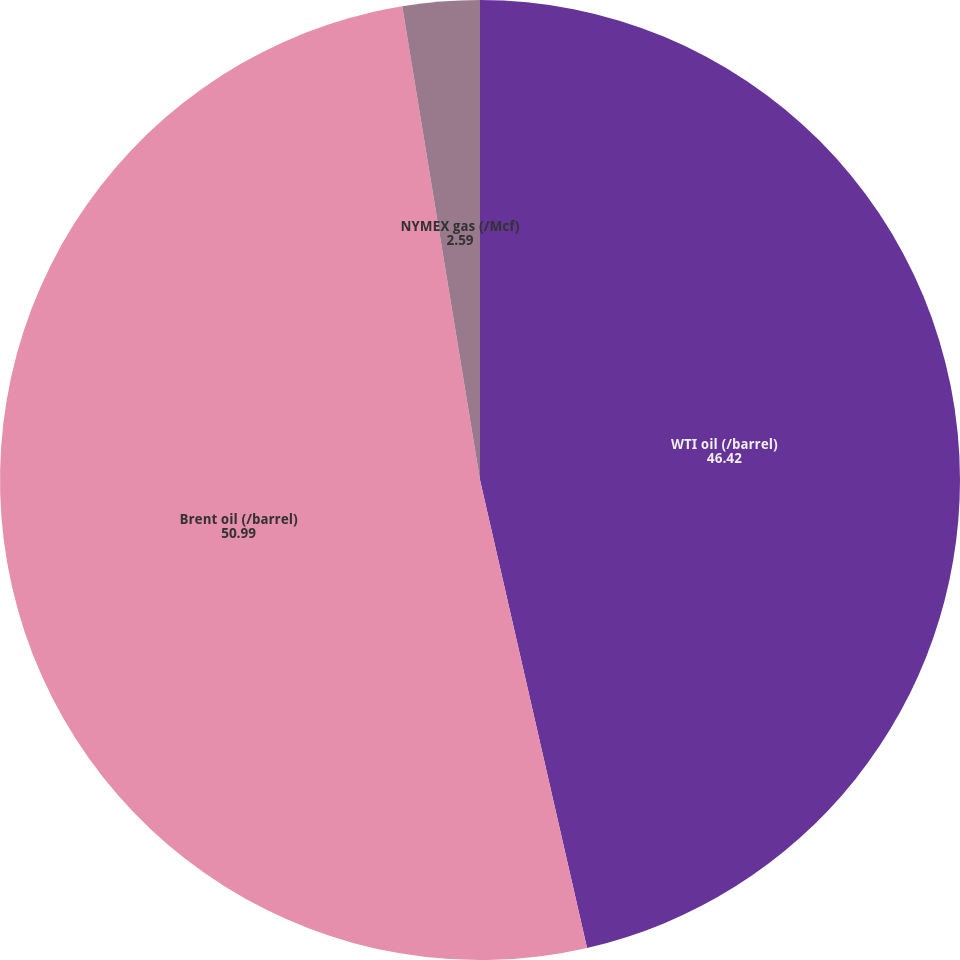Convert chart to OTSL. <chart><loc_0><loc_0><loc_500><loc_500><pie_chart><fcel>WTI oil (/barrel)<fcel>Brent oil (/barrel)<fcel>NYMEX gas (/Mcf)<nl><fcel>46.42%<fcel>50.99%<fcel>2.59%<nl></chart> 